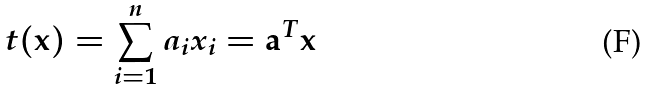Convert formula to latex. <formula><loc_0><loc_0><loc_500><loc_500>t ( { \mathbf x } ) = \sum _ { i = 1 } ^ { n } a _ { i } x _ { i } = { \mathbf a } ^ { T } { \mathbf x }</formula> 